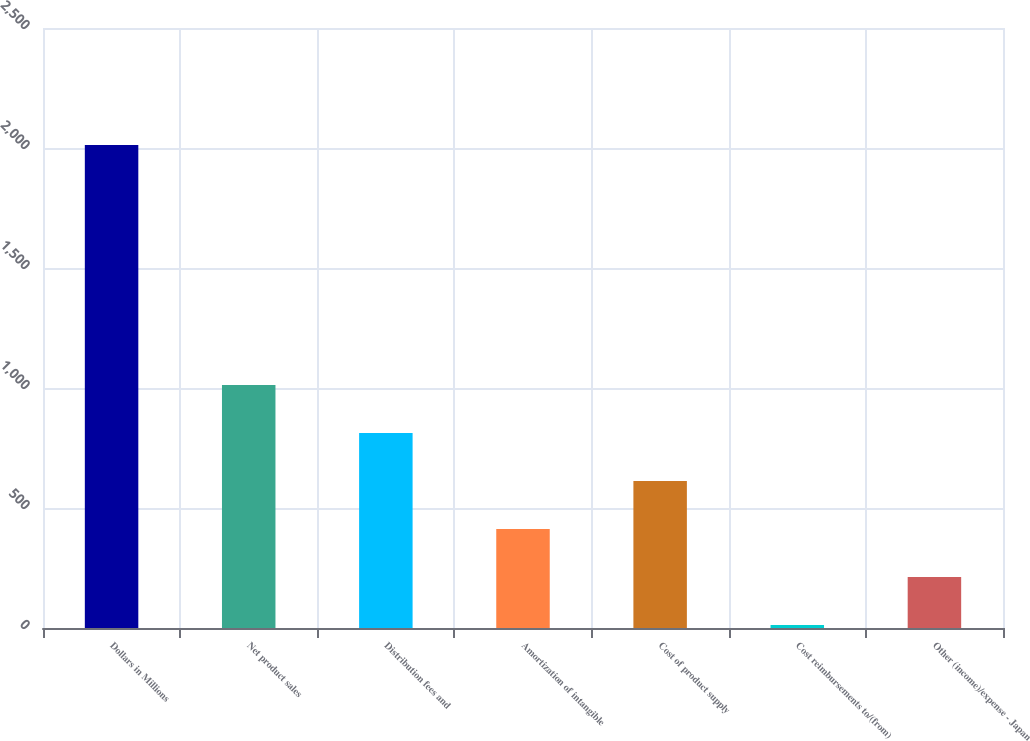Convert chart. <chart><loc_0><loc_0><loc_500><loc_500><bar_chart><fcel>Dollars in Millions<fcel>Net product sales<fcel>Distribution fees and<fcel>Amortization of intangible<fcel>Cost of product supply<fcel>Cost reimbursements to/(from)<fcel>Other (income)/expense - Japan<nl><fcel>2013<fcel>1013<fcel>813<fcel>413<fcel>613<fcel>13<fcel>213<nl></chart> 